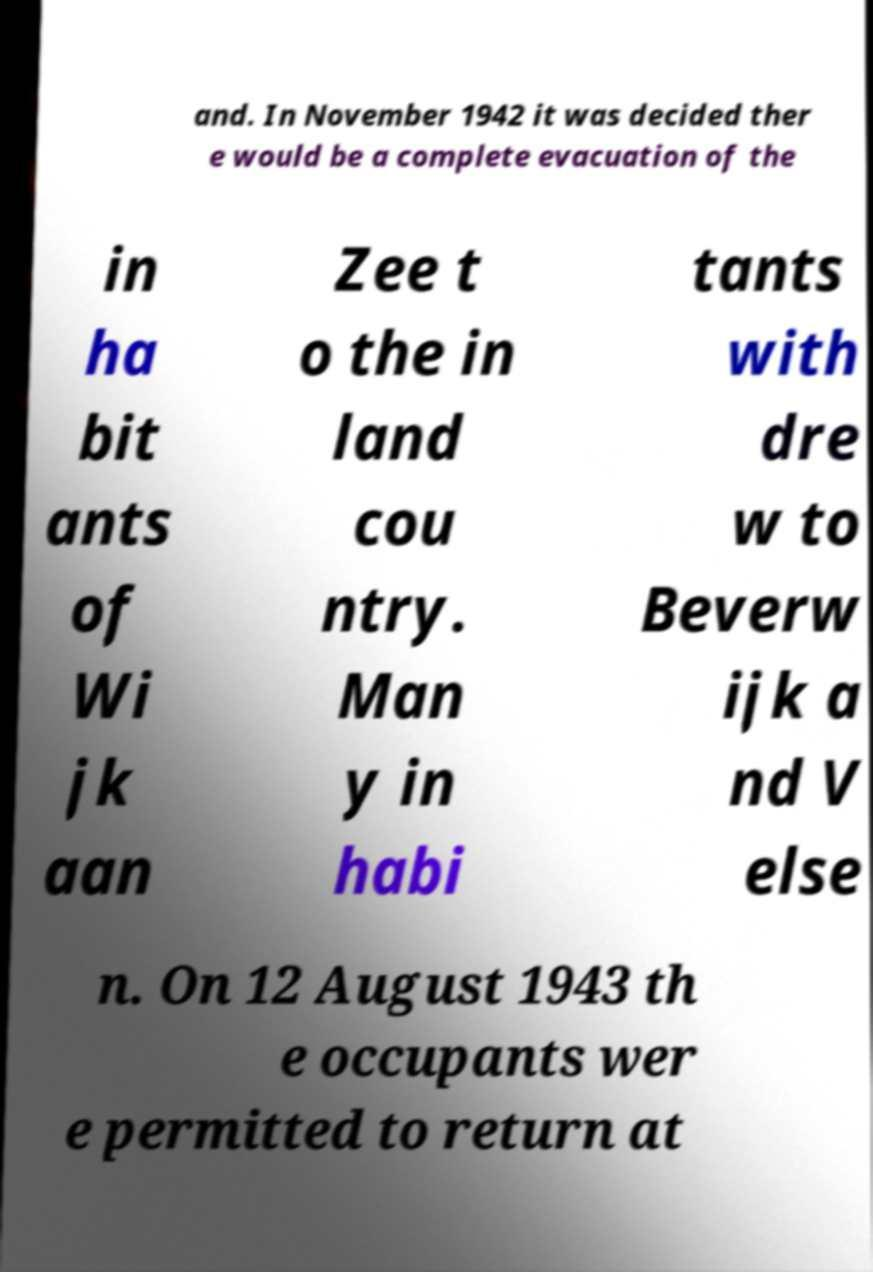Please read and relay the text visible in this image. What does it say? and. In November 1942 it was decided ther e would be a complete evacuation of the in ha bit ants of Wi jk aan Zee t o the in land cou ntry. Man y in habi tants with dre w to Beverw ijk a nd V else n. On 12 August 1943 th e occupants wer e permitted to return at 